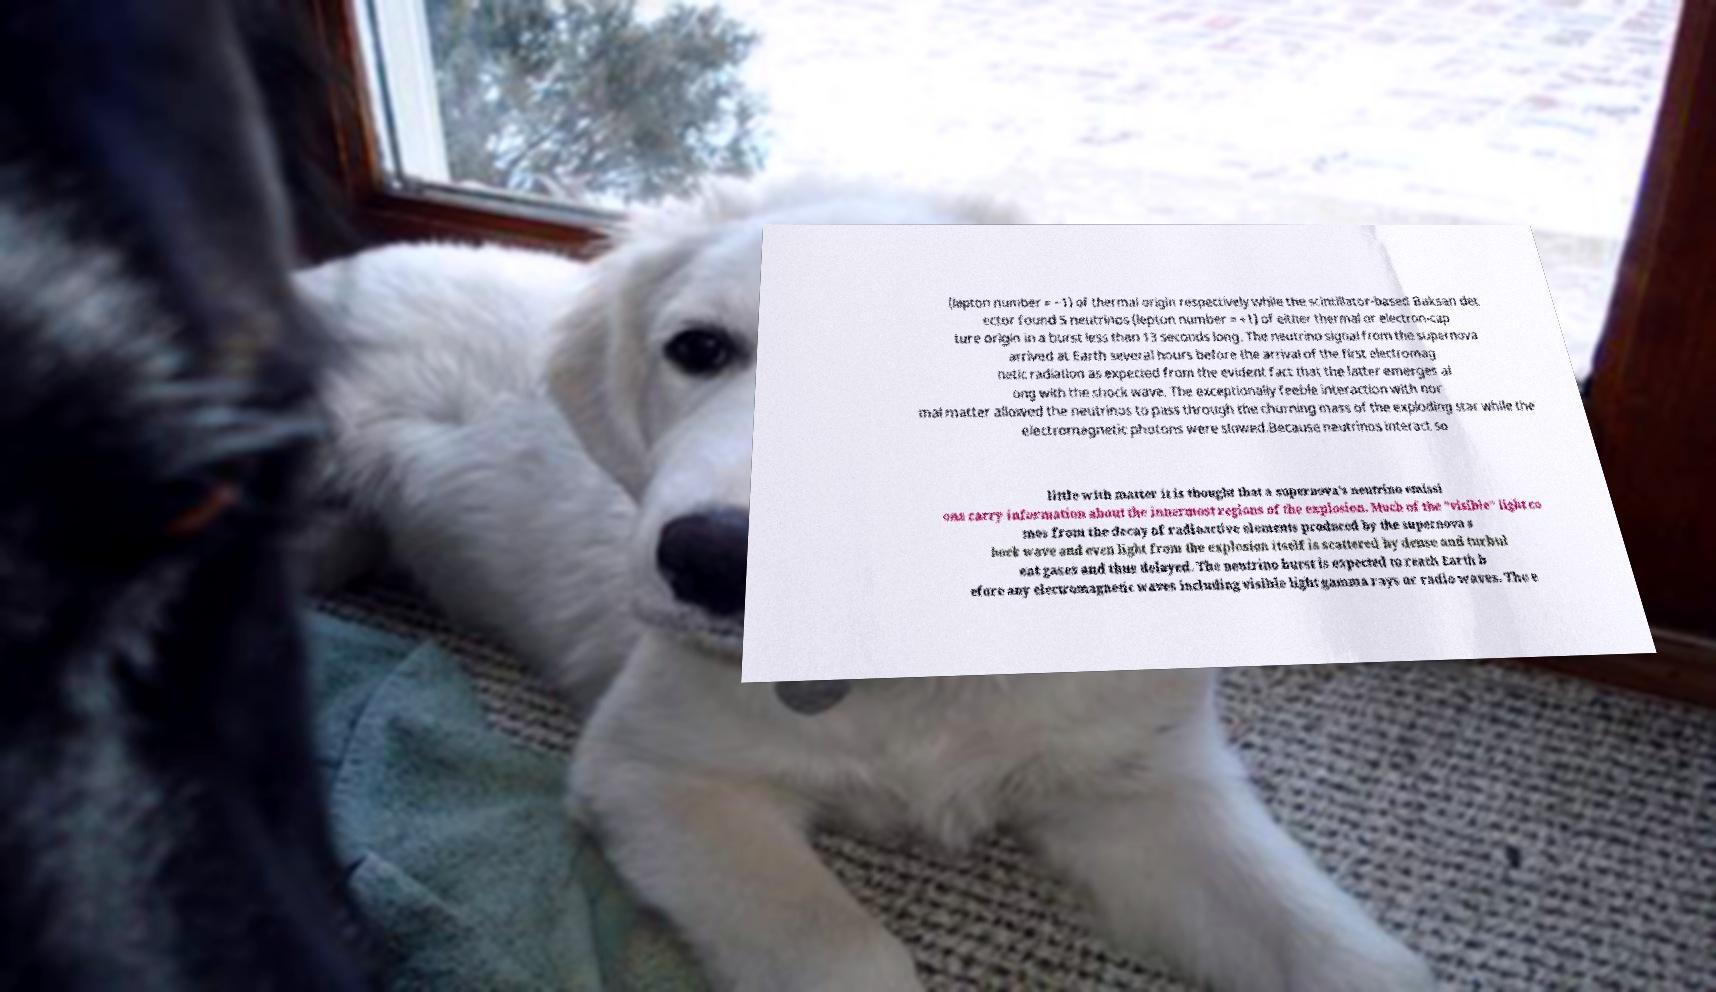Could you assist in decoding the text presented in this image and type it out clearly? (lepton number = −1) of thermal origin respectively while the scintillator-based Baksan det ector found 5 neutrinos (lepton number = +1) of either thermal or electron-cap ture origin in a burst less than 13 seconds long. The neutrino signal from the supernova arrived at Earth several hours before the arrival of the first electromag netic radiation as expected from the evident fact that the latter emerges al ong with the shock wave. The exceptionally feeble interaction with nor mal matter allowed the neutrinos to pass through the churning mass of the exploding star while the electromagnetic photons were slowed.Because neutrinos interact so little with matter it is thought that a supernova's neutrino emissi ons carry information about the innermost regions of the explosion. Much of the "visible" light co mes from the decay of radioactive elements produced by the supernova s hock wave and even light from the explosion itself is scattered by dense and turbul ent gases and thus delayed. The neutrino burst is expected to reach Earth b efore any electromagnetic waves including visible light gamma rays or radio waves. The e 